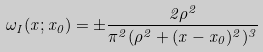Convert formula to latex. <formula><loc_0><loc_0><loc_500><loc_500>\omega _ { I } ( x ; x _ { 0 } ) = \pm \frac { 2 \rho ^ { 2 } } { \pi ^ { 2 } ( \rho ^ { 2 } + ( x - x _ { 0 } ) ^ { 2 } ) ^ { 3 } }</formula> 